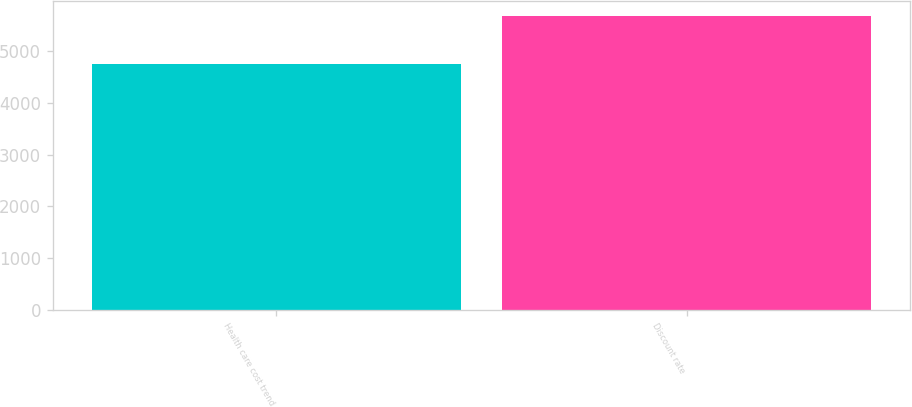Convert chart. <chart><loc_0><loc_0><loc_500><loc_500><bar_chart><fcel>Health care cost trend<fcel>Discount rate<nl><fcel>4751<fcel>5677<nl></chart> 